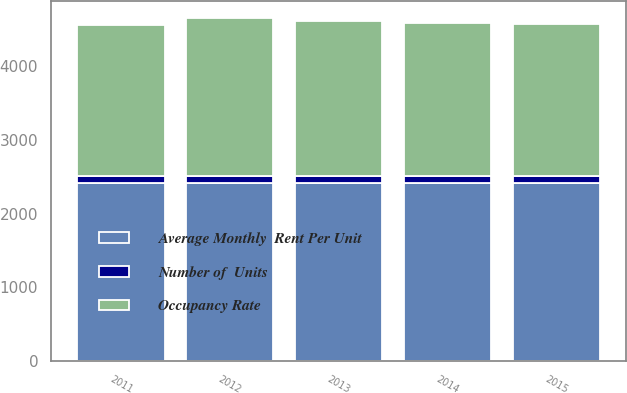Convert chart to OTSL. <chart><loc_0><loc_0><loc_500><loc_500><stacked_bar_chart><ecel><fcel>2015<fcel>2014<fcel>2013<fcel>2012<fcel>2011<nl><fcel>Average Monthly  Rent Per Unit<fcel>2414<fcel>2414<fcel>2414<fcel>2414<fcel>2414<nl><fcel>Number of  Units<fcel>96.1<fcel>97.4<fcel>96.3<fcel>97.9<fcel>96.6<nl><fcel>Occupancy Rate<fcel>2068<fcel>2078<fcel>2101<fcel>2145<fcel>2056<nl></chart> 